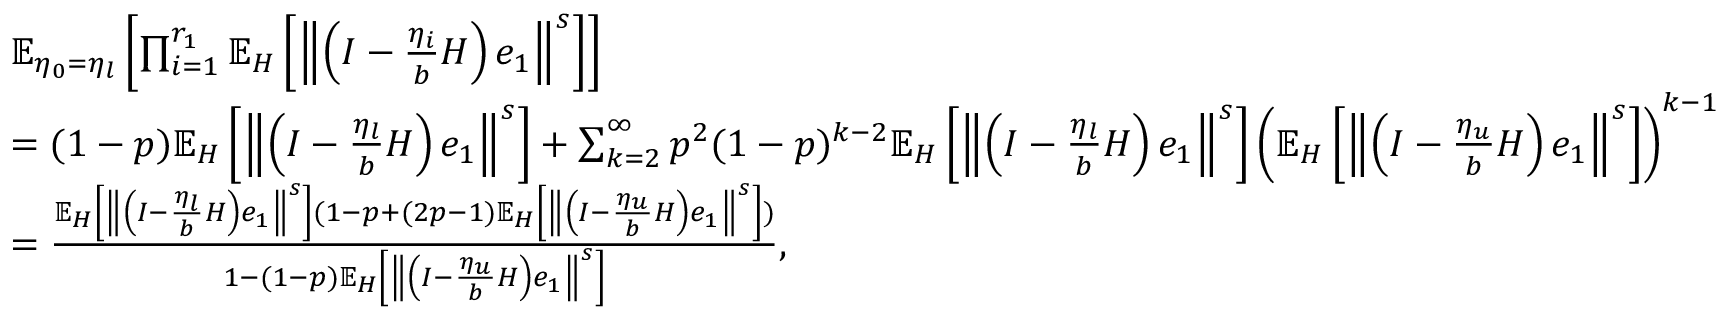<formula> <loc_0><loc_0><loc_500><loc_500>\begin{array} { r l } & { \mathbb { E } _ { \eta _ { 0 } = \eta _ { l } } \left [ \prod _ { i = 1 } ^ { r _ { 1 } } \mathbb { E } _ { H } \left [ \left \| \left ( I - \frac { \eta _ { i } } { b } H \right ) e _ { 1 } \right \| ^ { s } \right ] \right ] } \\ & { = ( 1 - p ) \mathbb { E } _ { H } \left [ \left \| \left ( I - \frac { \eta _ { l } } { b } H \right ) e _ { 1 } \right \| ^ { s } \right ] + \sum _ { k = 2 } ^ { \infty } p ^ { 2 } ( 1 - p ) ^ { k - 2 } \mathbb { E } _ { H } \left [ \left \| \left ( I - \frac { \eta _ { l } } { b } H \right ) e _ { 1 } \right \| ^ { s } \right ] \left ( \mathbb { E } _ { H } \left [ \left \| \left ( I - \frac { \eta _ { u } } { b } H \right ) e _ { 1 } \right \| ^ { s } \right ] \right ) ^ { k - 1 } } \\ & { = \frac { \mathbb { E } _ { H } \left [ \left \| \left ( I - \frac { \eta _ { l } } { b } H \right ) e _ { 1 } \right \| ^ { s } \right ] ( 1 - p + ( 2 p - 1 ) \mathbb { E } _ { H } \left [ \left \| \left ( I - \frac { \eta _ { u } } { b } H \right ) e _ { 1 } \right \| ^ { s } \right ] ) } { 1 - ( 1 - p ) \mathbb { E } _ { H } \left [ \left \| \left ( I - \frac { \eta _ { u } } { b } H \right ) e _ { 1 } \right \| ^ { s } \right ] } , } \end{array}</formula> 